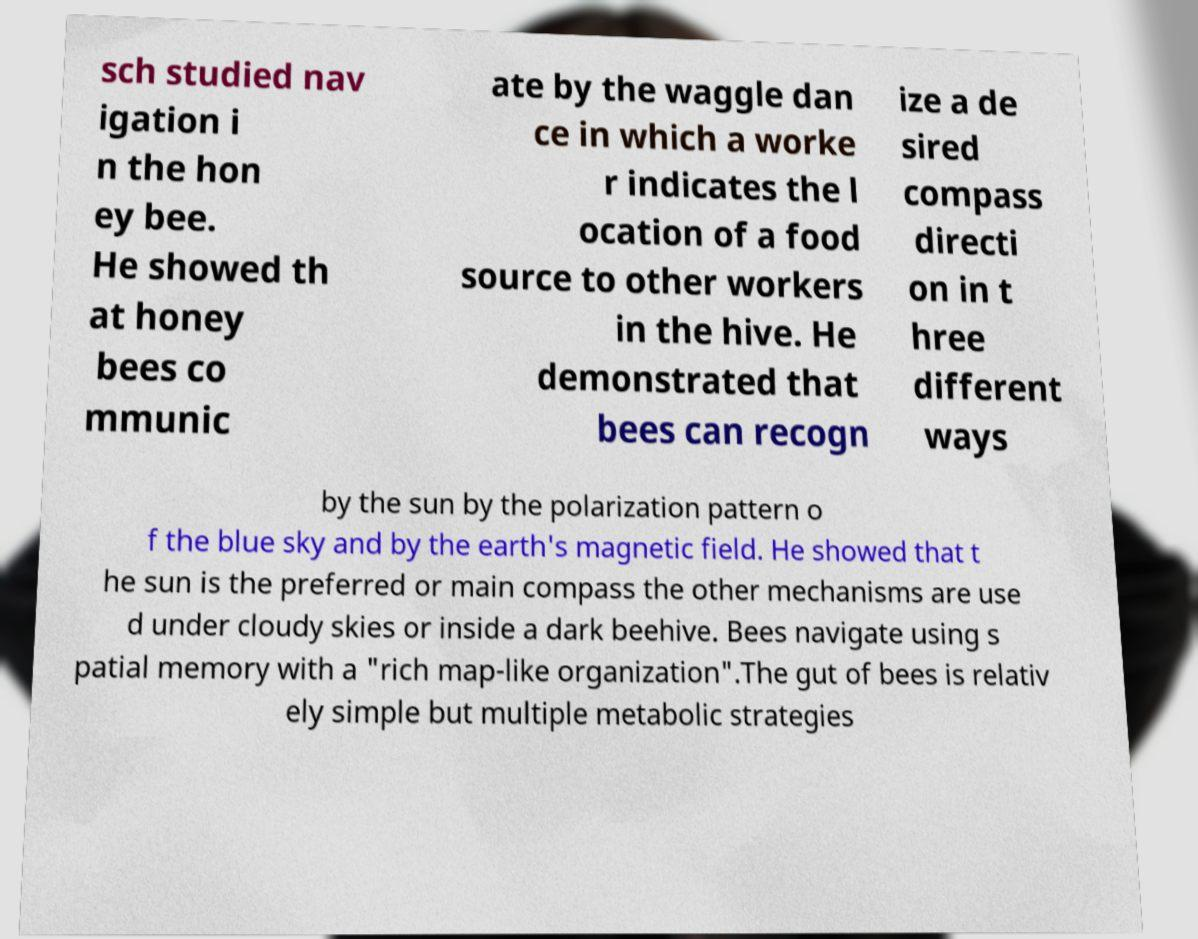Can you read and provide the text displayed in the image?This photo seems to have some interesting text. Can you extract and type it out for me? sch studied nav igation i n the hon ey bee. He showed th at honey bees co mmunic ate by the waggle dan ce in which a worke r indicates the l ocation of a food source to other workers in the hive. He demonstrated that bees can recogn ize a de sired compass directi on in t hree different ways by the sun by the polarization pattern o f the blue sky and by the earth's magnetic field. He showed that t he sun is the preferred or main compass the other mechanisms are use d under cloudy skies or inside a dark beehive. Bees navigate using s patial memory with a "rich map-like organization".The gut of bees is relativ ely simple but multiple metabolic strategies 